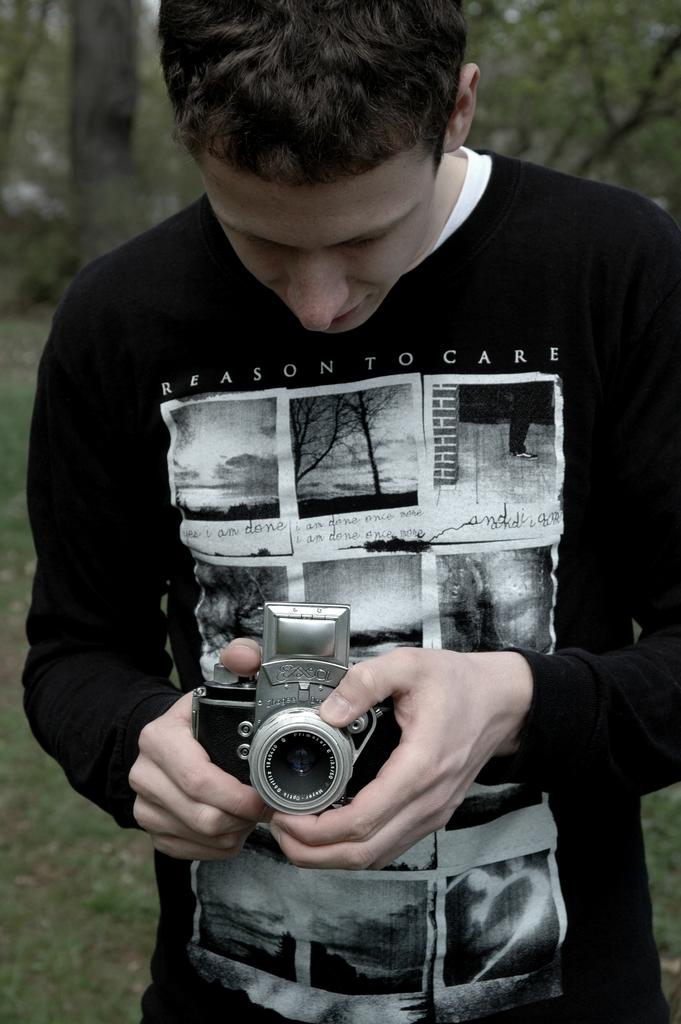Who is present in the image? There is a person in the image. What is the person wearing? The person is wearing a black shirt. Where is the person located in the image? The person is standing in the middle of the image. What is the person holding? The person is holding a camera. What can be seen in the background of the image? There are trees visible in the background of the image. What type of breakfast is the person eating in the image? There is no breakfast present in the image; the person is holding a camera. 